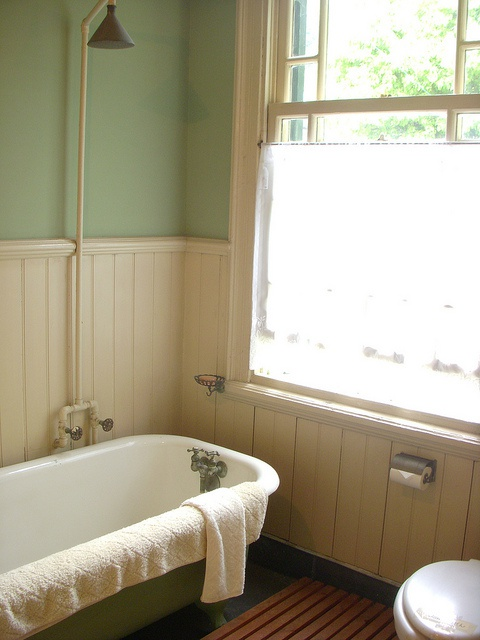Describe the objects in this image and their specific colors. I can see a toilet in darkgreen, lightgray, darkgray, and gray tones in this image. 